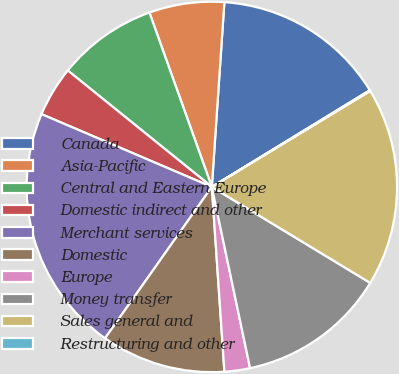<chart> <loc_0><loc_0><loc_500><loc_500><pie_chart><fcel>Canada<fcel>Asia-Pacific<fcel>Central and Eastern Europe<fcel>Domestic indirect and other<fcel>Merchant services<fcel>Domestic<fcel>Europe<fcel>Money transfer<fcel>Sales general and<fcel>Restructuring and other<nl><fcel>15.18%<fcel>6.55%<fcel>8.71%<fcel>4.39%<fcel>21.65%<fcel>10.86%<fcel>2.23%<fcel>13.02%<fcel>17.34%<fcel>0.07%<nl></chart> 